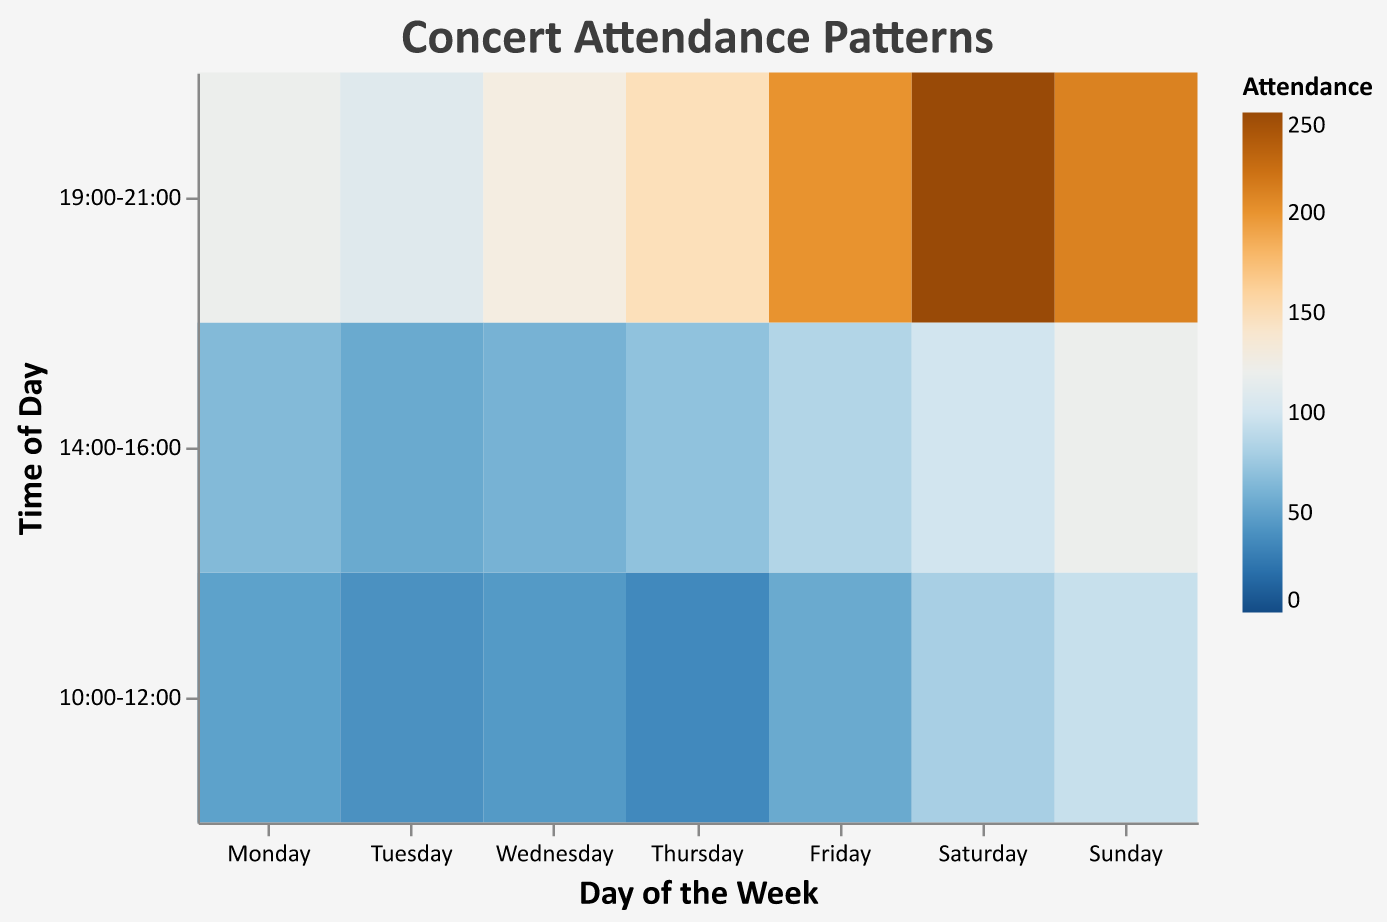What's the title of the heatmap? The title is displayed at the top of the heatmap. It is "Concert Attendance Patterns."
Answer: Concert Attendance Patterns On which day and time slot is the attendance the highest? By examining the heatmap, the darkest cell represents the highest attendance. This cell is found on Saturday from 19:00 to 21:00 with an attendance of 250.
Answer: Saturday, 19:00-21:00 What is the attendance for concerts on Wednesday from 10:00 to 12:00? Locate the cell corresponding to Wednesday and the time slot from 10:00-12:00 on the heatmap. The attendance value for this time slot is 45.
Answer: 45 How does the attendance on Sunday from 14:00 to 16:00 compare to Thursday from 14:00 to 16:00? Compare the color intensity of the cells for these two time slots. The attendance on Sunday from 14:00 to 16:00 is 120, which is greater than the 70 on Thursday for the same time slot.
Answer: Sunday, 14:00-16:00 > Thursday, 14:00-16:00 What average attendance can be observed for concerts occurring from 19:00 to 21:00 across all days? Sum the attendance values for 19:00-21:00 across all days and divide by the number of days. Total = 120 (Mon) + 110 (Tue) + 130 (Wed) + 150 (Thu) + 200 (Fri) + 250 (Sat) + 210 (Sun) = 1170. There are 7 days, so the average is 1170/7 = 167.14.
Answer: 167.14 Which time slot shows the lowest overall attendance during the week? Identify the overall attandance for each time slot. Add the attendance values for each time slot across all days: 
10:00-12:00: 50 + 40 + 45 + 35 + 55 + 80 + 95 = 400
14:00-16:00: 65 + 55 + 60 + 70 + 85 + 100 + 120 = 555
19:00-21:00: 120 + 110 + 130 + 150 + 200 + 250 + 210 = 1170
The time slot with the lowest overall attendance is 10:00-12:00.
Answer: 10:00-12:00 Is attendance during weekdays generally higher, lower, or about the same compared to weekends? Compare the average attendance of weekdays (Monday to Friday) against weekends (Saturday and Sunday). 
Weekday attendance sum: 50+65+120+40+55+110+45+60+130+35+70+150+55+85+200 = 1325
Divide by 5 days: 1325/5 = 265
Weekend attendance sum: 80+100+250+95+120+210 = 855
Divide by 2 days: 855/2 = 427.5
Weekday average is 265 compared to the weekend average of 427.5. Therefore, weekend attendance is generally higher.
Answer: Higher on weekends Which day's mid-day concerts (14:00-16:00) have the highest attendance? Compare the attendance for concerts from 14:00-16:00 across all days. The values are:
Monday: 65
Tuesday: 55
Wednesday: 60
Thursday: 70
Friday: 85
Saturday: 100
Sunday: 120
The highest attendance is on Sunday with 120.
Answer: Sunday What pattern can be observed regarding attendance trends later in the day (19:00 - 21:00) during weekends compared to weekdays? Review the attendance numbers for the 19:00-21:00 slot. Weekdays are Monday to Friday and weekends are Saturday and Sunday.
Weekday attendance is generally lower: 
Monday: 120
Tuesday: 110
Wednesday: 130
Thursday: 150
Friday: 200
Weekend attendance:
Saturday: 250
Sunday: 210
Attendance is higher during weekends in the 19:00-21:00 slot.
Answer: Higher on weekends 